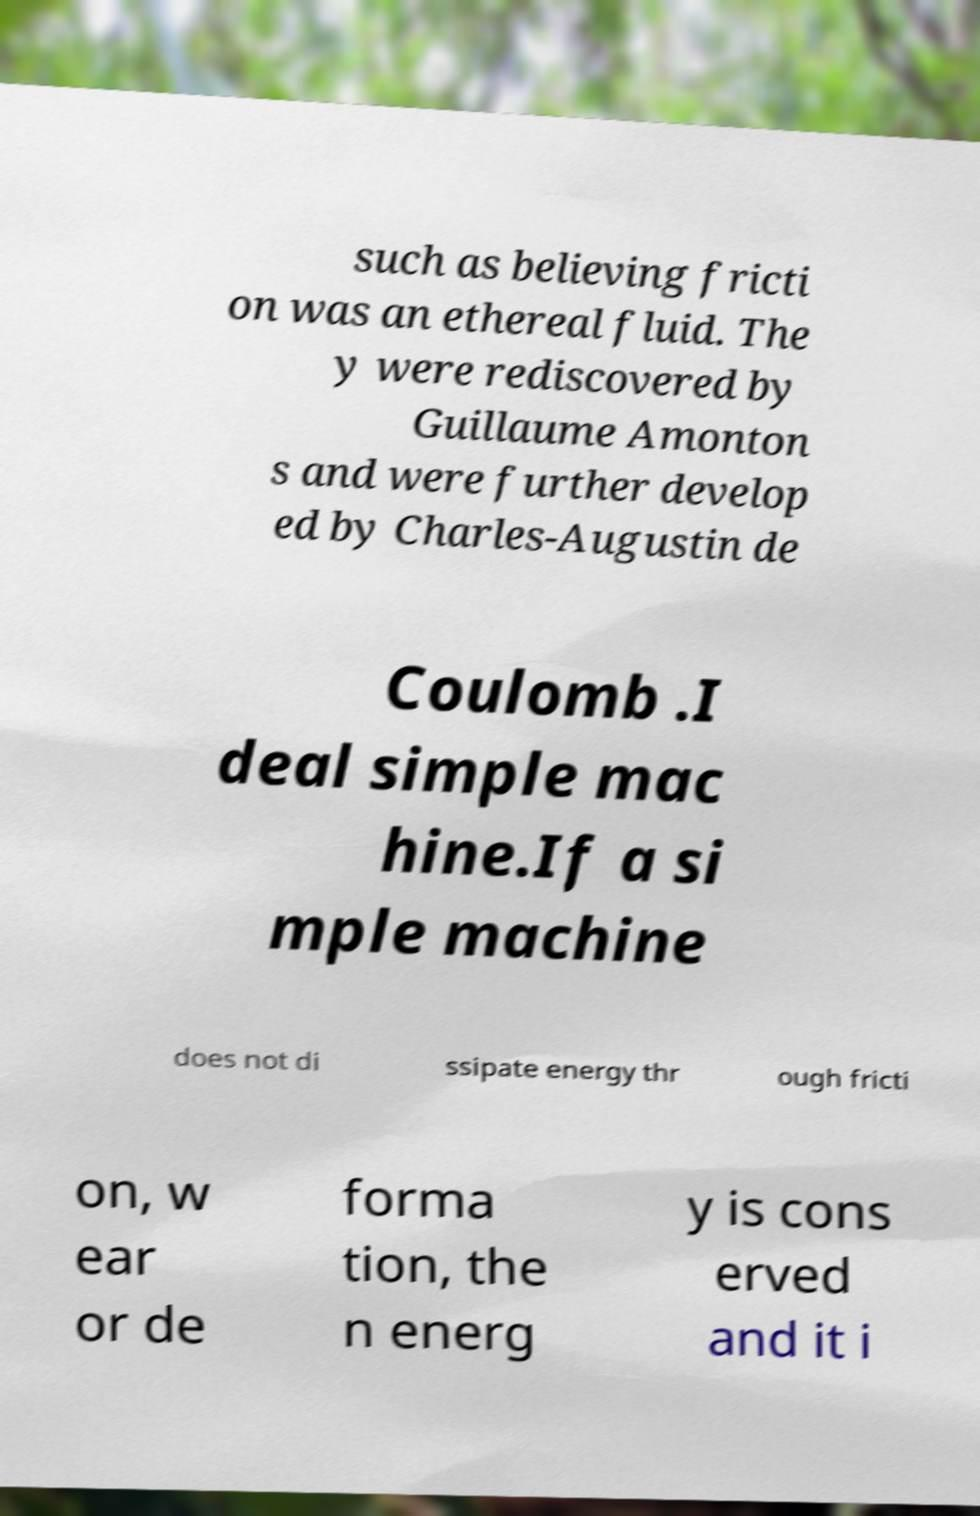Could you assist in decoding the text presented in this image and type it out clearly? such as believing fricti on was an ethereal fluid. The y were rediscovered by Guillaume Amonton s and were further develop ed by Charles-Augustin de Coulomb .I deal simple mac hine.If a si mple machine does not di ssipate energy thr ough fricti on, w ear or de forma tion, the n energ y is cons erved and it i 